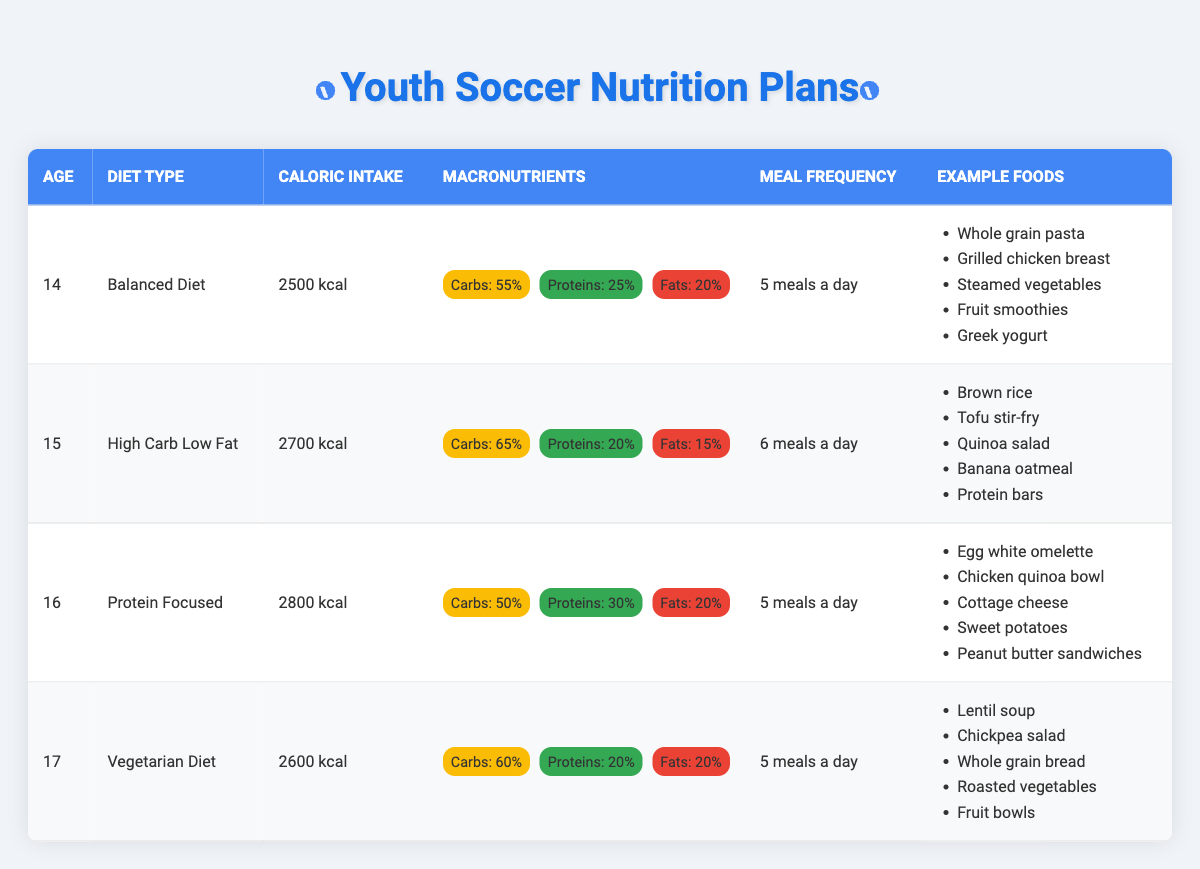What is the caloric intake for a 15-year-old player? The table shows that for a 15-year-old player following a High Carb Low Fat diet, the caloric intake is listed directly as 2700 kcal.
Answer: 2700 kcal Which diet type has the highest protein percentage? Analyzing the macronutrient percentages, the Protein Focused diet for a 16-year-old player contains 30% protein, which is the highest percentage compared to others.
Answer: Protein Focused Is the meal frequency consistent among all the age groups? The table indicates that players aged 14, 16, and 17 all follow a meal frequency of 5 meals a day, while the 15-year-old player follows 6 meals a day, indicating inconsistency.
Answer: No What is the average caloric intake for players aged 14, 15, and 16? For players aged 14 (2500 kcal), 15 (2700 kcal), and 16 (2800 kcal), the total caloric intake is 2500 + 2700 + 2800 = 8000 kcal. Dividing by 3 gives an average of 8000 / 3 = approximately 2666.67 kcal.
Answer: Approximately 2666.67 kcal Are there more vegetarian food items than non-vegetarian food items in the example foods section? Counting the example foods for the Vegetarian Diet (5 items) and the other diets (4 items each for Balanced, High Carb Low Fat, and Protein Focused which total 12 non-vegetarian items), indicating a majority of non-vegetarian options.
Answer: No Which diet type has the lowest fat percentage? By comparing the fat percentages in each diet type, the High Carb Low Fat diet for the 15-year-old has the lowest fat percentage of 15%.
Answer: High Carb Low Fat What are the two main components of a Balanced Diet for a 14-year-old? Referring to the macronutrient breakdown for a 14-year-old Balanced Diet, it consists of carbohydrates at 55% and proteins at 25%.
Answer: Carbohydrates and proteins If a 17-year-old player follows a Vegetarian Diet, how many grams of fats can they consume if they are on a 2600 kcal intake? First, calculate 20% of 2600 kcal for fats. This is 0.20 * 2600 = 520 kcal from fats. Since fats have 9 kcal per gram, divide by 9 to get the grams: 520 / 9 = approximately 57.78 grams of fat.
Answer: Approximately 57.78 grams 